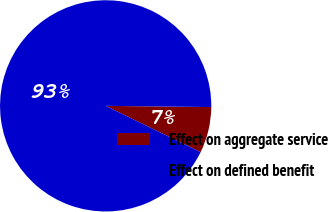Convert chart. <chart><loc_0><loc_0><loc_500><loc_500><pie_chart><fcel>Effect on aggregate service<fcel>Effect on defined benefit<nl><fcel>7.04%<fcel>92.96%<nl></chart> 